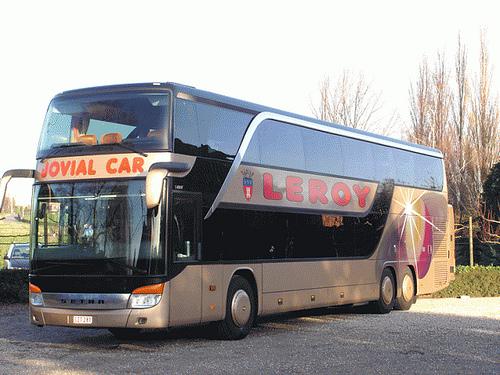Is this a tour bus?
Write a very short answer. Yes. How many wheels are on the bus?
Short answer required. 6. Where is this bus going?
Give a very brief answer. Nowhere. Which side is the driver?
Give a very brief answer. Right. Are there buildings in the picture?
Short answer required. No. Where is the bus parked?
Keep it brief. Parking lot. Is this a bus?
Quick response, please. Yes. What color is the bus in the picture?
Be succinct. Black. Is this bus part of a transportation line?
Concise answer only. Yes. 